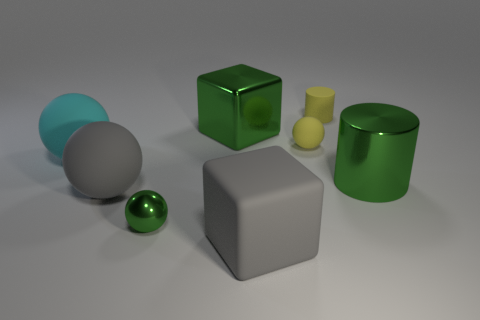Add 1 large blocks. How many objects exist? 9 Subtract all cubes. How many objects are left? 6 Add 4 rubber cylinders. How many rubber cylinders are left? 5 Add 4 purple cylinders. How many purple cylinders exist? 4 Subtract 0 red balls. How many objects are left? 8 Subtract all tiny green metal spheres. Subtract all cyan things. How many objects are left? 6 